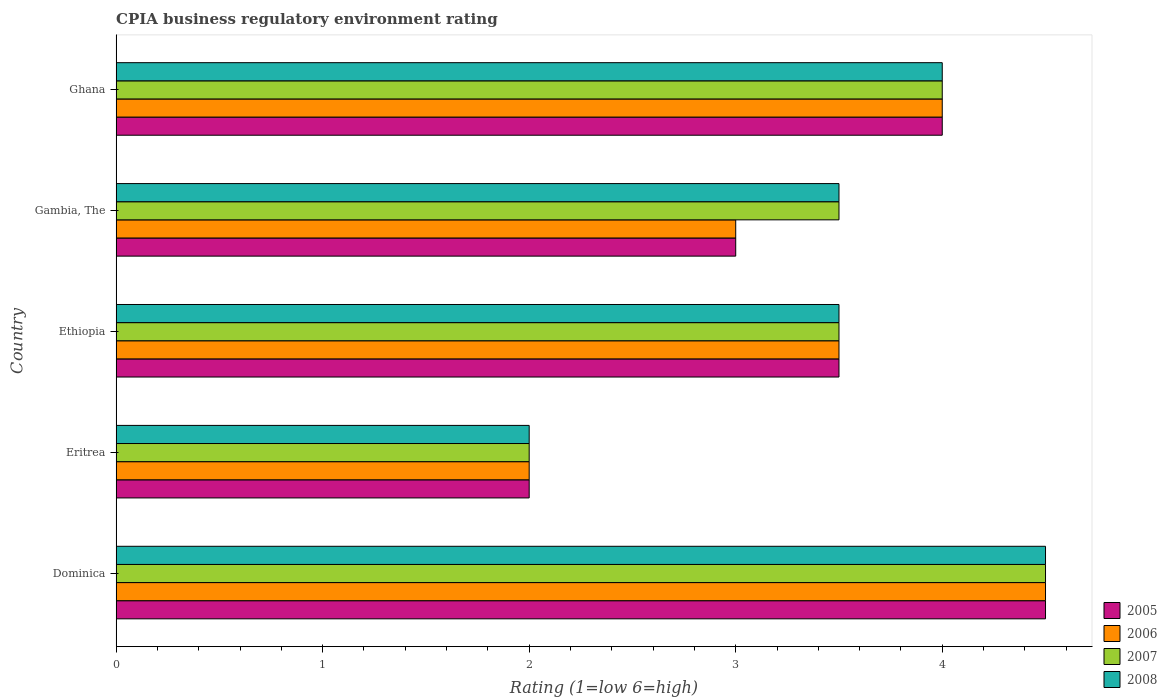Are the number of bars on each tick of the Y-axis equal?
Provide a short and direct response. Yes. How many bars are there on the 4th tick from the top?
Your answer should be very brief. 4. How many bars are there on the 1st tick from the bottom?
Ensure brevity in your answer.  4. What is the label of the 4th group of bars from the top?
Ensure brevity in your answer.  Eritrea. In how many cases, is the number of bars for a given country not equal to the number of legend labels?
Offer a very short reply. 0. In which country was the CPIA rating in 2007 maximum?
Provide a short and direct response. Dominica. In which country was the CPIA rating in 2008 minimum?
Ensure brevity in your answer.  Eritrea. What is the difference between the CPIA rating in 2005 in Ethiopia and that in Gambia, The?
Your response must be concise. 0.5. What is the difference between the CPIA rating in 2005 in Eritrea and the CPIA rating in 2007 in Gambia, The?
Provide a succinct answer. -1.5. In how many countries, is the CPIA rating in 2007 greater than 2.8 ?
Give a very brief answer. 4. What is the ratio of the CPIA rating in 2008 in Dominica to that in Ghana?
Provide a succinct answer. 1.12. Is the difference between the CPIA rating in 2007 in Dominica and Ghana greater than the difference between the CPIA rating in 2005 in Dominica and Ghana?
Keep it short and to the point. No. What is the difference between the highest and the second highest CPIA rating in 2007?
Give a very brief answer. 0.5. How many bars are there?
Your answer should be very brief. 20. What is the difference between two consecutive major ticks on the X-axis?
Provide a succinct answer. 1. Are the values on the major ticks of X-axis written in scientific E-notation?
Provide a short and direct response. No. Does the graph contain any zero values?
Keep it short and to the point. No. Does the graph contain grids?
Your answer should be very brief. No. How many legend labels are there?
Provide a short and direct response. 4. How are the legend labels stacked?
Provide a short and direct response. Vertical. What is the title of the graph?
Provide a succinct answer. CPIA business regulatory environment rating. Does "2015" appear as one of the legend labels in the graph?
Make the answer very short. No. What is the Rating (1=low 6=high) of 2005 in Dominica?
Ensure brevity in your answer.  4.5. What is the Rating (1=low 6=high) of 2006 in Dominica?
Provide a short and direct response. 4.5. What is the Rating (1=low 6=high) in 2007 in Dominica?
Offer a terse response. 4.5. What is the Rating (1=low 6=high) in 2008 in Dominica?
Make the answer very short. 4.5. What is the Rating (1=low 6=high) in 2005 in Eritrea?
Make the answer very short. 2. What is the Rating (1=low 6=high) in 2006 in Eritrea?
Offer a terse response. 2. What is the Rating (1=low 6=high) in 2008 in Eritrea?
Ensure brevity in your answer.  2. What is the Rating (1=low 6=high) in 2005 in Ethiopia?
Make the answer very short. 3.5. What is the Rating (1=low 6=high) in 2008 in Ethiopia?
Your response must be concise. 3.5. What is the Rating (1=low 6=high) of 2007 in Gambia, The?
Ensure brevity in your answer.  3.5. What is the Rating (1=low 6=high) of 2008 in Gambia, The?
Offer a very short reply. 3.5. What is the Rating (1=low 6=high) in 2005 in Ghana?
Offer a very short reply. 4. What is the Rating (1=low 6=high) of 2007 in Ghana?
Provide a succinct answer. 4. What is the Rating (1=low 6=high) of 2008 in Ghana?
Make the answer very short. 4. Across all countries, what is the maximum Rating (1=low 6=high) in 2005?
Offer a very short reply. 4.5. Across all countries, what is the maximum Rating (1=low 6=high) of 2006?
Offer a very short reply. 4.5. Across all countries, what is the maximum Rating (1=low 6=high) of 2008?
Your answer should be very brief. 4.5. Across all countries, what is the minimum Rating (1=low 6=high) of 2005?
Offer a terse response. 2. Across all countries, what is the minimum Rating (1=low 6=high) of 2007?
Your answer should be very brief. 2. Across all countries, what is the minimum Rating (1=low 6=high) of 2008?
Offer a terse response. 2. What is the total Rating (1=low 6=high) of 2008 in the graph?
Your answer should be compact. 17.5. What is the difference between the Rating (1=low 6=high) of 2005 in Dominica and that in Eritrea?
Offer a very short reply. 2.5. What is the difference between the Rating (1=low 6=high) of 2006 in Dominica and that in Eritrea?
Your answer should be compact. 2.5. What is the difference between the Rating (1=low 6=high) in 2008 in Dominica and that in Eritrea?
Provide a succinct answer. 2.5. What is the difference between the Rating (1=low 6=high) of 2005 in Dominica and that in Ethiopia?
Ensure brevity in your answer.  1. What is the difference between the Rating (1=low 6=high) of 2006 in Dominica and that in Ethiopia?
Your answer should be very brief. 1. What is the difference between the Rating (1=low 6=high) in 2007 in Dominica and that in Ethiopia?
Your response must be concise. 1. What is the difference between the Rating (1=low 6=high) in 2008 in Dominica and that in Ethiopia?
Your answer should be compact. 1. What is the difference between the Rating (1=low 6=high) of 2007 in Dominica and that in Gambia, The?
Make the answer very short. 1. What is the difference between the Rating (1=low 6=high) in 2008 in Dominica and that in Gambia, The?
Your answer should be compact. 1. What is the difference between the Rating (1=low 6=high) in 2007 in Dominica and that in Ghana?
Keep it short and to the point. 0.5. What is the difference between the Rating (1=low 6=high) in 2008 in Dominica and that in Ghana?
Make the answer very short. 0.5. What is the difference between the Rating (1=low 6=high) of 2006 in Eritrea and that in Ethiopia?
Offer a terse response. -1.5. What is the difference between the Rating (1=low 6=high) in 2007 in Eritrea and that in Ethiopia?
Give a very brief answer. -1.5. What is the difference between the Rating (1=low 6=high) of 2005 in Eritrea and that in Gambia, The?
Ensure brevity in your answer.  -1. What is the difference between the Rating (1=low 6=high) of 2006 in Eritrea and that in Gambia, The?
Give a very brief answer. -1. What is the difference between the Rating (1=low 6=high) in 2008 in Eritrea and that in Gambia, The?
Keep it short and to the point. -1.5. What is the difference between the Rating (1=low 6=high) of 2006 in Eritrea and that in Ghana?
Give a very brief answer. -2. What is the difference between the Rating (1=low 6=high) of 2007 in Eritrea and that in Ghana?
Offer a terse response. -2. What is the difference between the Rating (1=low 6=high) of 2008 in Eritrea and that in Ghana?
Your response must be concise. -2. What is the difference between the Rating (1=low 6=high) of 2005 in Ethiopia and that in Gambia, The?
Give a very brief answer. 0.5. What is the difference between the Rating (1=low 6=high) in 2006 in Ethiopia and that in Gambia, The?
Keep it short and to the point. 0.5. What is the difference between the Rating (1=low 6=high) in 2005 in Ethiopia and that in Ghana?
Keep it short and to the point. -0.5. What is the difference between the Rating (1=low 6=high) of 2006 in Ethiopia and that in Ghana?
Offer a terse response. -0.5. What is the difference between the Rating (1=low 6=high) of 2008 in Ethiopia and that in Ghana?
Ensure brevity in your answer.  -0.5. What is the difference between the Rating (1=low 6=high) in 2005 in Gambia, The and that in Ghana?
Offer a terse response. -1. What is the difference between the Rating (1=low 6=high) in 2006 in Gambia, The and that in Ghana?
Your answer should be very brief. -1. What is the difference between the Rating (1=low 6=high) in 2005 in Dominica and the Rating (1=low 6=high) in 2006 in Eritrea?
Ensure brevity in your answer.  2.5. What is the difference between the Rating (1=low 6=high) in 2005 in Dominica and the Rating (1=low 6=high) in 2007 in Eritrea?
Keep it short and to the point. 2.5. What is the difference between the Rating (1=low 6=high) of 2005 in Dominica and the Rating (1=low 6=high) of 2008 in Eritrea?
Give a very brief answer. 2.5. What is the difference between the Rating (1=low 6=high) of 2005 in Dominica and the Rating (1=low 6=high) of 2006 in Ethiopia?
Provide a succinct answer. 1. What is the difference between the Rating (1=low 6=high) of 2005 in Dominica and the Rating (1=low 6=high) of 2008 in Gambia, The?
Give a very brief answer. 1. What is the difference between the Rating (1=low 6=high) of 2006 in Dominica and the Rating (1=low 6=high) of 2007 in Gambia, The?
Provide a succinct answer. 1. What is the difference between the Rating (1=low 6=high) of 2005 in Dominica and the Rating (1=low 6=high) of 2006 in Ghana?
Offer a very short reply. 0.5. What is the difference between the Rating (1=low 6=high) in 2006 in Dominica and the Rating (1=low 6=high) in 2007 in Ghana?
Provide a succinct answer. 0.5. What is the difference between the Rating (1=low 6=high) in 2006 in Dominica and the Rating (1=low 6=high) in 2008 in Ghana?
Provide a short and direct response. 0.5. What is the difference between the Rating (1=low 6=high) in 2005 in Eritrea and the Rating (1=low 6=high) in 2008 in Ethiopia?
Make the answer very short. -1.5. What is the difference between the Rating (1=low 6=high) in 2006 in Eritrea and the Rating (1=low 6=high) in 2007 in Ethiopia?
Ensure brevity in your answer.  -1.5. What is the difference between the Rating (1=low 6=high) of 2006 in Eritrea and the Rating (1=low 6=high) of 2008 in Ethiopia?
Ensure brevity in your answer.  -1.5. What is the difference between the Rating (1=low 6=high) in 2007 in Eritrea and the Rating (1=low 6=high) in 2008 in Ethiopia?
Your answer should be compact. -1.5. What is the difference between the Rating (1=low 6=high) in 2005 in Eritrea and the Rating (1=low 6=high) in 2007 in Gambia, The?
Your answer should be very brief. -1.5. What is the difference between the Rating (1=low 6=high) of 2006 in Eritrea and the Rating (1=low 6=high) of 2007 in Gambia, The?
Keep it short and to the point. -1.5. What is the difference between the Rating (1=low 6=high) of 2007 in Eritrea and the Rating (1=low 6=high) of 2008 in Gambia, The?
Your answer should be very brief. -1.5. What is the difference between the Rating (1=low 6=high) of 2005 in Eritrea and the Rating (1=low 6=high) of 2006 in Ghana?
Your answer should be compact. -2. What is the difference between the Rating (1=low 6=high) of 2006 in Eritrea and the Rating (1=low 6=high) of 2007 in Ghana?
Offer a very short reply. -2. What is the difference between the Rating (1=low 6=high) in 2007 in Eritrea and the Rating (1=low 6=high) in 2008 in Ghana?
Your answer should be compact. -2. What is the difference between the Rating (1=low 6=high) of 2005 in Ethiopia and the Rating (1=low 6=high) of 2006 in Gambia, The?
Offer a terse response. 0.5. What is the difference between the Rating (1=low 6=high) of 2005 in Ethiopia and the Rating (1=low 6=high) of 2007 in Gambia, The?
Ensure brevity in your answer.  0. What is the difference between the Rating (1=low 6=high) of 2005 in Ethiopia and the Rating (1=low 6=high) of 2008 in Gambia, The?
Make the answer very short. 0. What is the difference between the Rating (1=low 6=high) in 2006 in Ethiopia and the Rating (1=low 6=high) in 2007 in Gambia, The?
Keep it short and to the point. 0. What is the difference between the Rating (1=low 6=high) of 2007 in Ethiopia and the Rating (1=low 6=high) of 2008 in Gambia, The?
Provide a succinct answer. 0. What is the difference between the Rating (1=low 6=high) in 2005 in Ethiopia and the Rating (1=low 6=high) in 2006 in Ghana?
Ensure brevity in your answer.  -0.5. What is the difference between the Rating (1=low 6=high) of 2006 in Ethiopia and the Rating (1=low 6=high) of 2007 in Ghana?
Keep it short and to the point. -0.5. What is the difference between the Rating (1=low 6=high) in 2005 in Gambia, The and the Rating (1=low 6=high) in 2006 in Ghana?
Give a very brief answer. -1. What is the difference between the Rating (1=low 6=high) in 2005 in Gambia, The and the Rating (1=low 6=high) in 2007 in Ghana?
Ensure brevity in your answer.  -1. What is the difference between the Rating (1=low 6=high) of 2005 in Gambia, The and the Rating (1=low 6=high) of 2008 in Ghana?
Provide a succinct answer. -1. What is the average Rating (1=low 6=high) in 2007 per country?
Make the answer very short. 3.5. What is the average Rating (1=low 6=high) in 2008 per country?
Your response must be concise. 3.5. What is the difference between the Rating (1=low 6=high) in 2005 and Rating (1=low 6=high) in 2007 in Dominica?
Offer a terse response. 0. What is the difference between the Rating (1=low 6=high) in 2005 and Rating (1=low 6=high) in 2008 in Dominica?
Make the answer very short. 0. What is the difference between the Rating (1=low 6=high) in 2006 and Rating (1=low 6=high) in 2007 in Dominica?
Your answer should be very brief. 0. What is the difference between the Rating (1=low 6=high) of 2006 and Rating (1=low 6=high) of 2008 in Dominica?
Offer a terse response. 0. What is the difference between the Rating (1=low 6=high) in 2005 and Rating (1=low 6=high) in 2007 in Eritrea?
Offer a terse response. 0. What is the difference between the Rating (1=low 6=high) in 2007 and Rating (1=low 6=high) in 2008 in Eritrea?
Your response must be concise. 0. What is the difference between the Rating (1=low 6=high) in 2005 and Rating (1=low 6=high) in 2006 in Ethiopia?
Ensure brevity in your answer.  0. What is the difference between the Rating (1=low 6=high) of 2005 and Rating (1=low 6=high) of 2007 in Ethiopia?
Offer a terse response. 0. What is the difference between the Rating (1=low 6=high) in 2006 and Rating (1=low 6=high) in 2007 in Ethiopia?
Ensure brevity in your answer.  0. What is the difference between the Rating (1=low 6=high) in 2007 and Rating (1=low 6=high) in 2008 in Ethiopia?
Provide a short and direct response. 0. What is the difference between the Rating (1=low 6=high) in 2005 and Rating (1=low 6=high) in 2007 in Gambia, The?
Offer a very short reply. -0.5. What is the difference between the Rating (1=low 6=high) in 2006 and Rating (1=low 6=high) in 2007 in Gambia, The?
Your answer should be very brief. -0.5. What is the difference between the Rating (1=low 6=high) of 2006 and Rating (1=low 6=high) of 2008 in Gambia, The?
Give a very brief answer. -0.5. What is the difference between the Rating (1=low 6=high) in 2007 and Rating (1=low 6=high) in 2008 in Gambia, The?
Your answer should be compact. 0. What is the difference between the Rating (1=low 6=high) of 2005 and Rating (1=low 6=high) of 2006 in Ghana?
Your answer should be very brief. 0. What is the difference between the Rating (1=low 6=high) of 2005 and Rating (1=low 6=high) of 2007 in Ghana?
Your answer should be very brief. 0. What is the ratio of the Rating (1=low 6=high) of 2005 in Dominica to that in Eritrea?
Provide a short and direct response. 2.25. What is the ratio of the Rating (1=low 6=high) of 2006 in Dominica to that in Eritrea?
Your answer should be very brief. 2.25. What is the ratio of the Rating (1=low 6=high) of 2007 in Dominica to that in Eritrea?
Your answer should be compact. 2.25. What is the ratio of the Rating (1=low 6=high) of 2008 in Dominica to that in Eritrea?
Keep it short and to the point. 2.25. What is the ratio of the Rating (1=low 6=high) of 2005 in Dominica to that in Gambia, The?
Ensure brevity in your answer.  1.5. What is the ratio of the Rating (1=low 6=high) of 2006 in Dominica to that in Gambia, The?
Your answer should be compact. 1.5. What is the ratio of the Rating (1=low 6=high) in 2006 in Dominica to that in Ghana?
Make the answer very short. 1.12. What is the ratio of the Rating (1=low 6=high) in 2007 in Dominica to that in Ghana?
Keep it short and to the point. 1.12. What is the ratio of the Rating (1=low 6=high) in 2008 in Dominica to that in Ghana?
Offer a terse response. 1.12. What is the ratio of the Rating (1=low 6=high) in 2005 in Eritrea to that in Ethiopia?
Your answer should be compact. 0.57. What is the ratio of the Rating (1=low 6=high) of 2005 in Eritrea to that in Gambia, The?
Your response must be concise. 0.67. What is the ratio of the Rating (1=low 6=high) in 2006 in Eritrea to that in Gambia, The?
Offer a very short reply. 0.67. What is the ratio of the Rating (1=low 6=high) in 2008 in Eritrea to that in Gambia, The?
Offer a terse response. 0.57. What is the ratio of the Rating (1=low 6=high) of 2005 in Eritrea to that in Ghana?
Provide a succinct answer. 0.5. What is the ratio of the Rating (1=low 6=high) in 2008 in Eritrea to that in Ghana?
Your answer should be very brief. 0.5. What is the ratio of the Rating (1=low 6=high) in 2005 in Ethiopia to that in Ghana?
Make the answer very short. 0.88. What is the ratio of the Rating (1=low 6=high) of 2006 in Ethiopia to that in Ghana?
Ensure brevity in your answer.  0.88. What is the ratio of the Rating (1=low 6=high) of 2008 in Ethiopia to that in Ghana?
Your answer should be compact. 0.88. What is the ratio of the Rating (1=low 6=high) of 2006 in Gambia, The to that in Ghana?
Give a very brief answer. 0.75. What is the ratio of the Rating (1=low 6=high) in 2007 in Gambia, The to that in Ghana?
Keep it short and to the point. 0.88. What is the ratio of the Rating (1=low 6=high) in 2008 in Gambia, The to that in Ghana?
Offer a terse response. 0.88. What is the difference between the highest and the second highest Rating (1=low 6=high) of 2006?
Give a very brief answer. 0.5. What is the difference between the highest and the lowest Rating (1=low 6=high) of 2006?
Your response must be concise. 2.5. What is the difference between the highest and the lowest Rating (1=low 6=high) of 2008?
Provide a succinct answer. 2.5. 